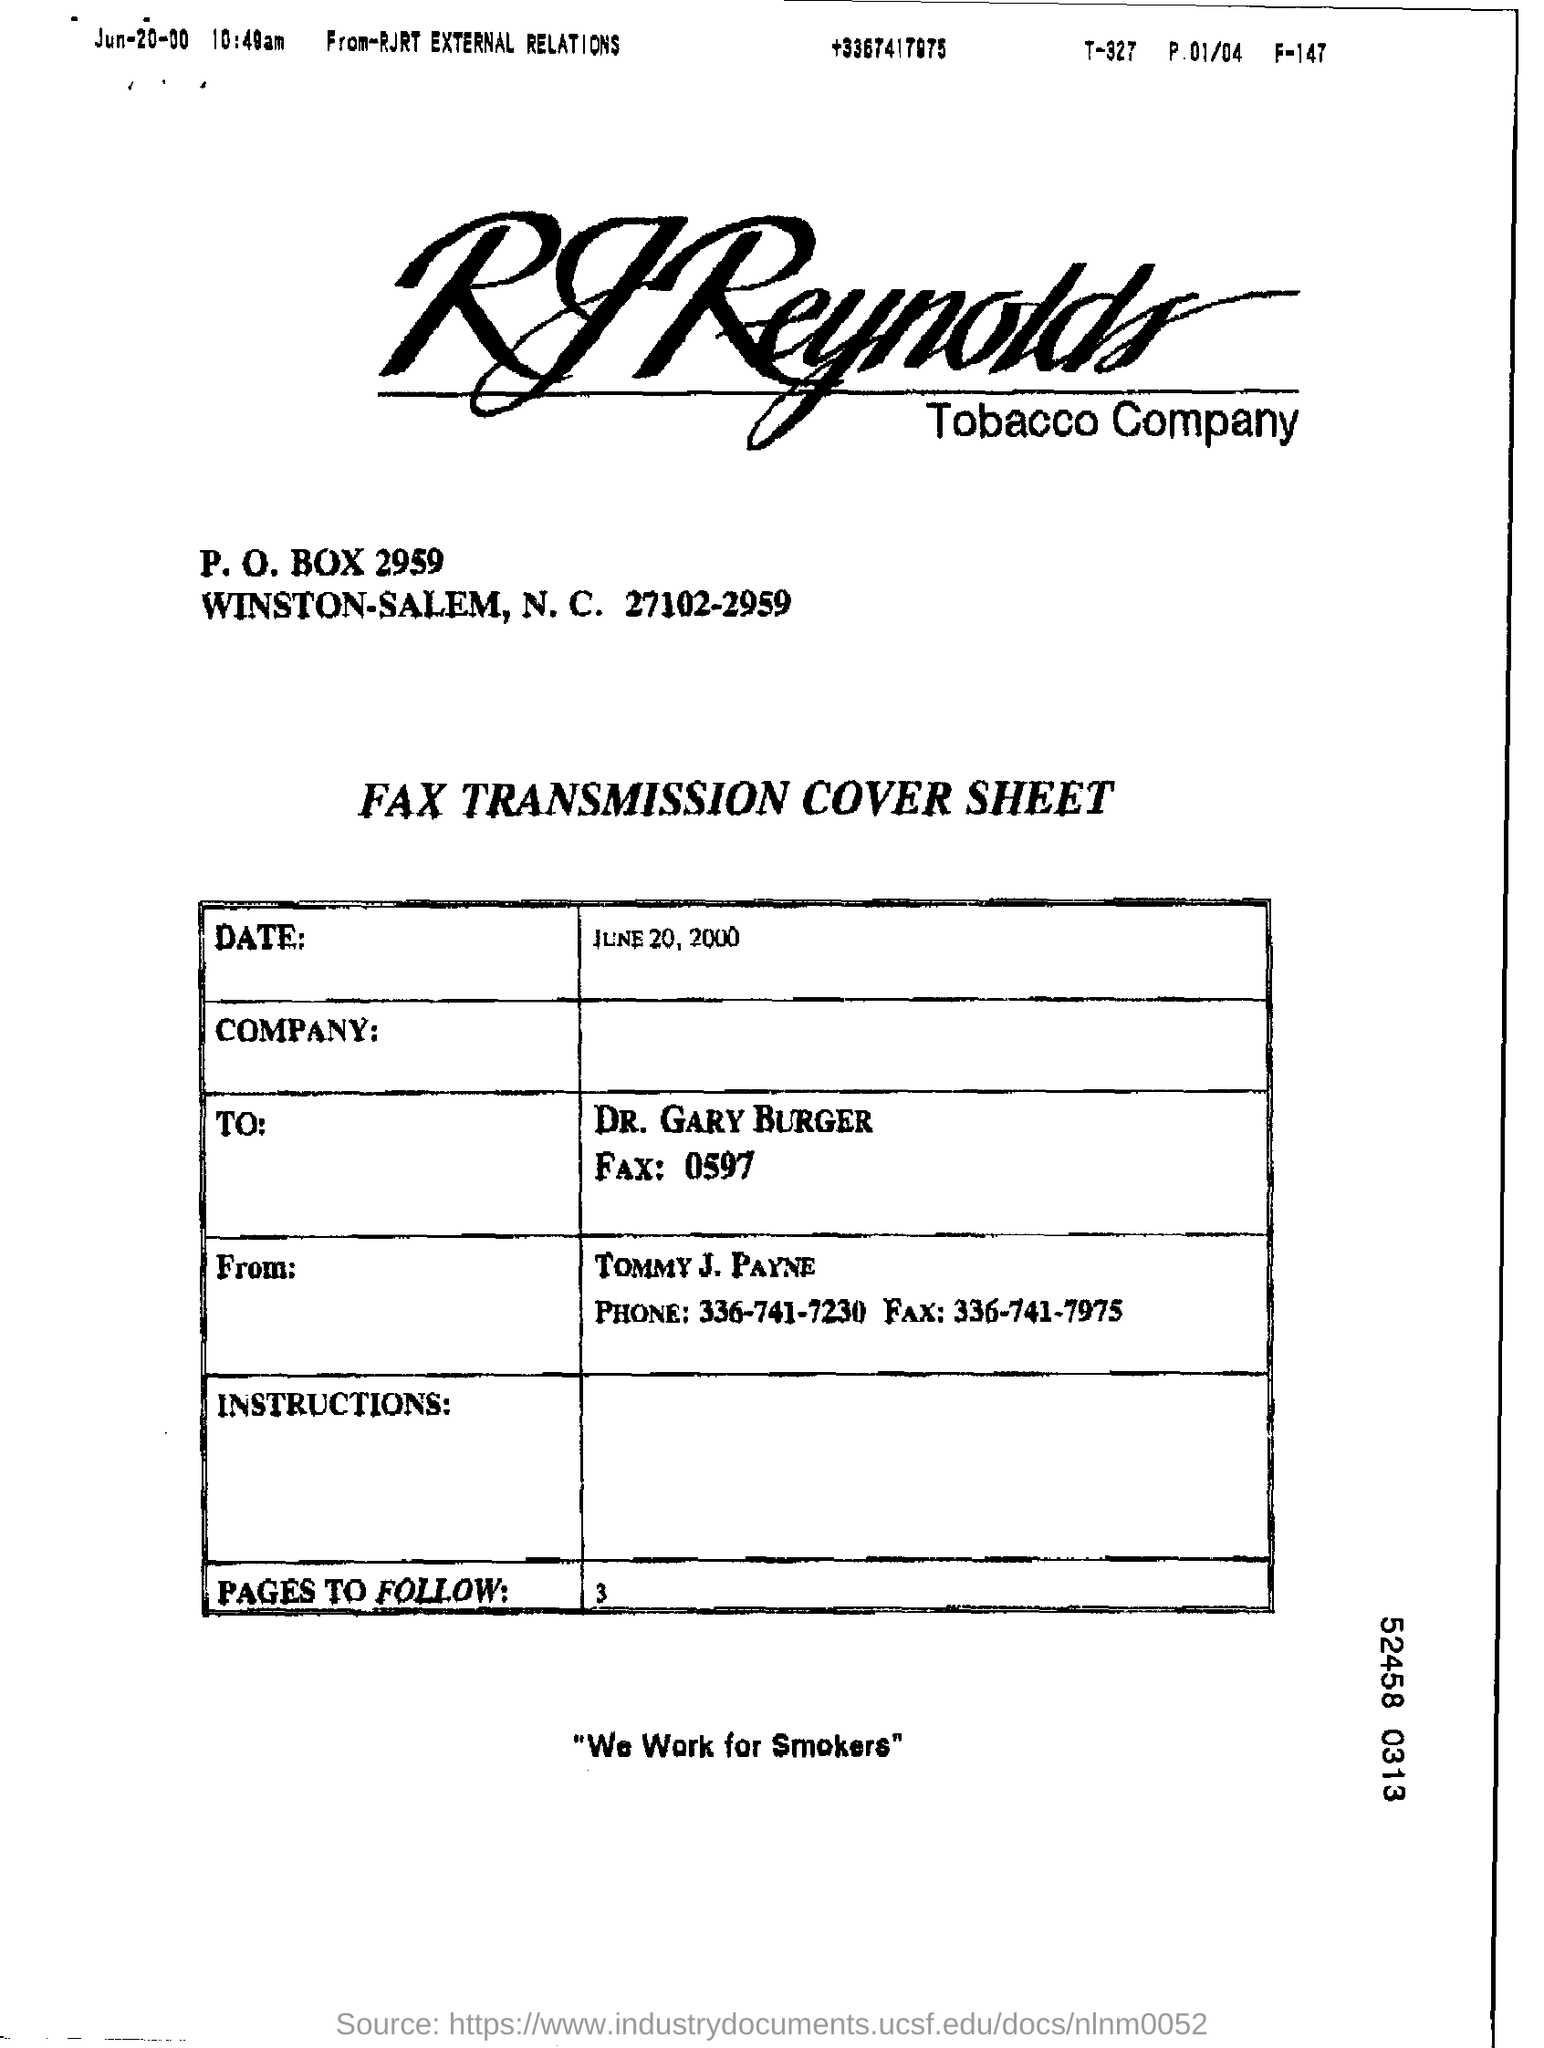Which company's name is at the top of the page?
Your answer should be very brief. RJ Reynolds Tobacco Company. Who is the sender?
Your answer should be compact. TOMMY J. PAYNE. What is the phrase written at the bottom of the page?
Keep it short and to the point. "We Work for Smokers". 